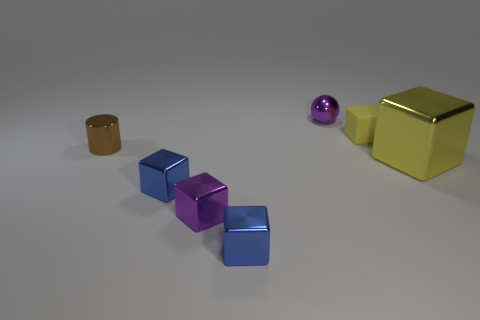Subtract all tiny cubes. How many cubes are left? 1 Subtract all purple blocks. How many blocks are left? 4 Subtract all brown cubes. Subtract all blue balls. How many cubes are left? 5 Add 1 small metal balls. How many objects exist? 8 Subtract all spheres. How many objects are left? 6 Subtract all blue cubes. Subtract all purple shiny cubes. How many objects are left? 4 Add 1 matte blocks. How many matte blocks are left? 2 Add 5 small blue shiny cubes. How many small blue shiny cubes exist? 7 Subtract 1 blue blocks. How many objects are left? 6 